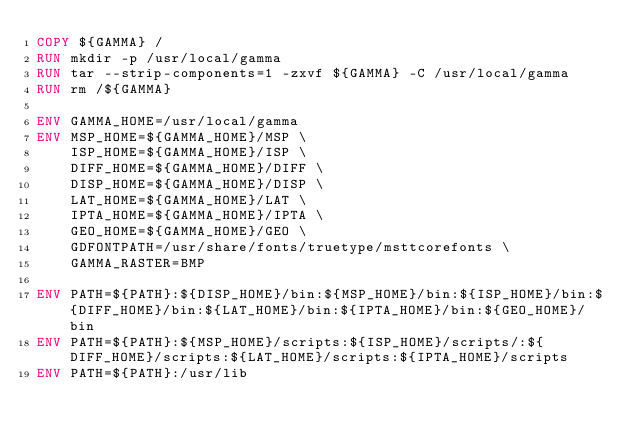Convert code to text. <code><loc_0><loc_0><loc_500><loc_500><_Dockerfile_>COPY ${GAMMA} /
RUN mkdir -p /usr/local/gamma
RUN tar --strip-components=1 -zxvf ${GAMMA} -C /usr/local/gamma
RUN rm /${GAMMA}

ENV GAMMA_HOME=/usr/local/gamma
ENV MSP_HOME=${GAMMA_HOME}/MSP \
    ISP_HOME=${GAMMA_HOME}/ISP \
    DIFF_HOME=${GAMMA_HOME}/DIFF \
    DISP_HOME=${GAMMA_HOME}/DISP \
    LAT_HOME=${GAMMA_HOME}/LAT \
    IPTA_HOME=${GAMMA_HOME}/IPTA \
    GEO_HOME=${GAMMA_HOME}/GEO \
    GDFONTPATH=/usr/share/fonts/truetype/msttcorefonts \
    GAMMA_RASTER=BMP

ENV PATH=${PATH}:${DISP_HOME}/bin:${MSP_HOME}/bin:${ISP_HOME}/bin:${DIFF_HOME}/bin:${LAT_HOME}/bin:${IPTA_HOME}/bin:${GEO_HOME}/bin
ENV PATH=${PATH}:${MSP_HOME}/scripts:${ISP_HOME}/scripts/:${DIFF_HOME}/scripts:${LAT_HOME}/scripts:${IPTA_HOME}/scripts
ENV PATH=${PATH}:/usr/lib
</code> 